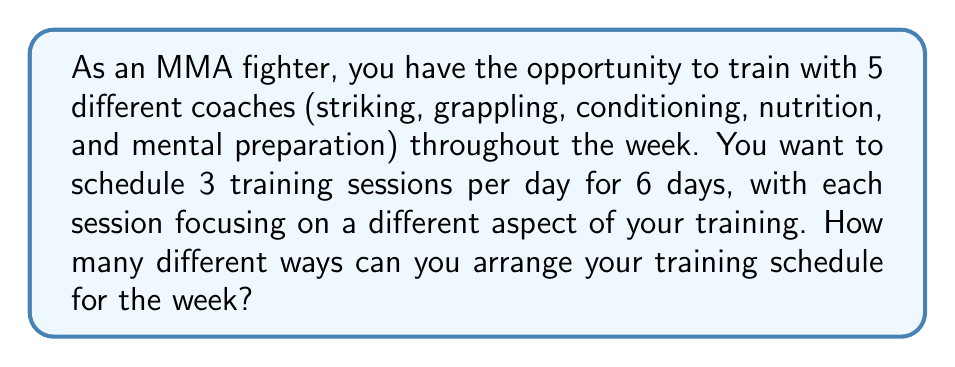What is the answer to this math problem? Let's approach this step-by-step:

1) For each day, we need to choose 3 coaches out of 5 available coaches.
   This is a combination problem, as the order doesn't matter within a day.

2) The number of ways to choose 3 coaches out of 5 for each day is:
   $$\binom{5}{3} = \frac{5!}{3!(5-3)!} = \frac{5 \cdot 4 \cdot 3}{3 \cdot 2 \cdot 1} = 10$$

3) Now, for each day, we need to arrange these 3 chosen coaches in a specific order.
   This is a permutation of 3 items, which is:
   $$P(3) = 3! = 3 \cdot 2 \cdot 1 = 6$$

4) So, for each day, the total number of arrangements is:
   $$10 \cdot 6 = 60$$

5) We need to do this for 6 days, and the choices for each day are independent.
   Therefore, we multiply the number of possibilities for each day:
   $$60^6$$

6) Thus, the total number of different ways to arrange the training schedule for the week is:
   $$60^6 = 46,656,000,000$$
Answer: $60^6 = 46,656,000,000$ 